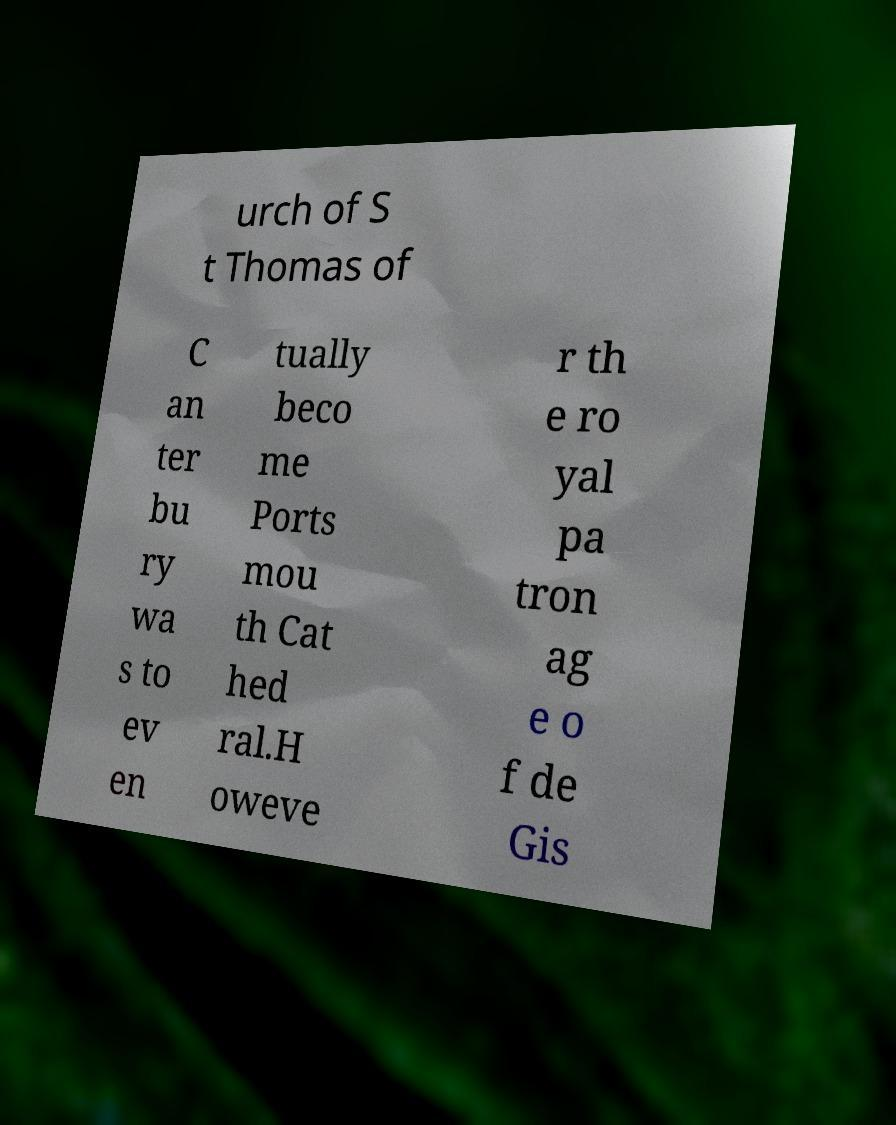For documentation purposes, I need the text within this image transcribed. Could you provide that? urch of S t Thomas of C an ter bu ry wa s to ev en tually beco me Ports mou th Cat hed ral.H oweve r th e ro yal pa tron ag e o f de Gis 